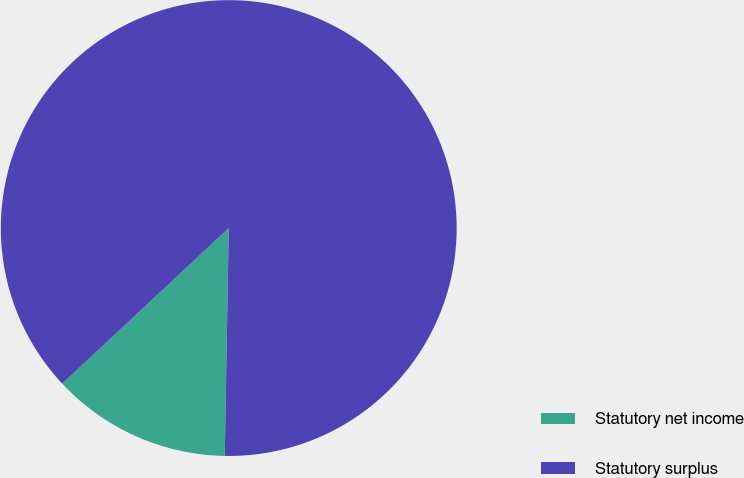Convert chart. <chart><loc_0><loc_0><loc_500><loc_500><pie_chart><fcel>Statutory net income<fcel>Statutory surplus<nl><fcel>12.76%<fcel>87.24%<nl></chart> 